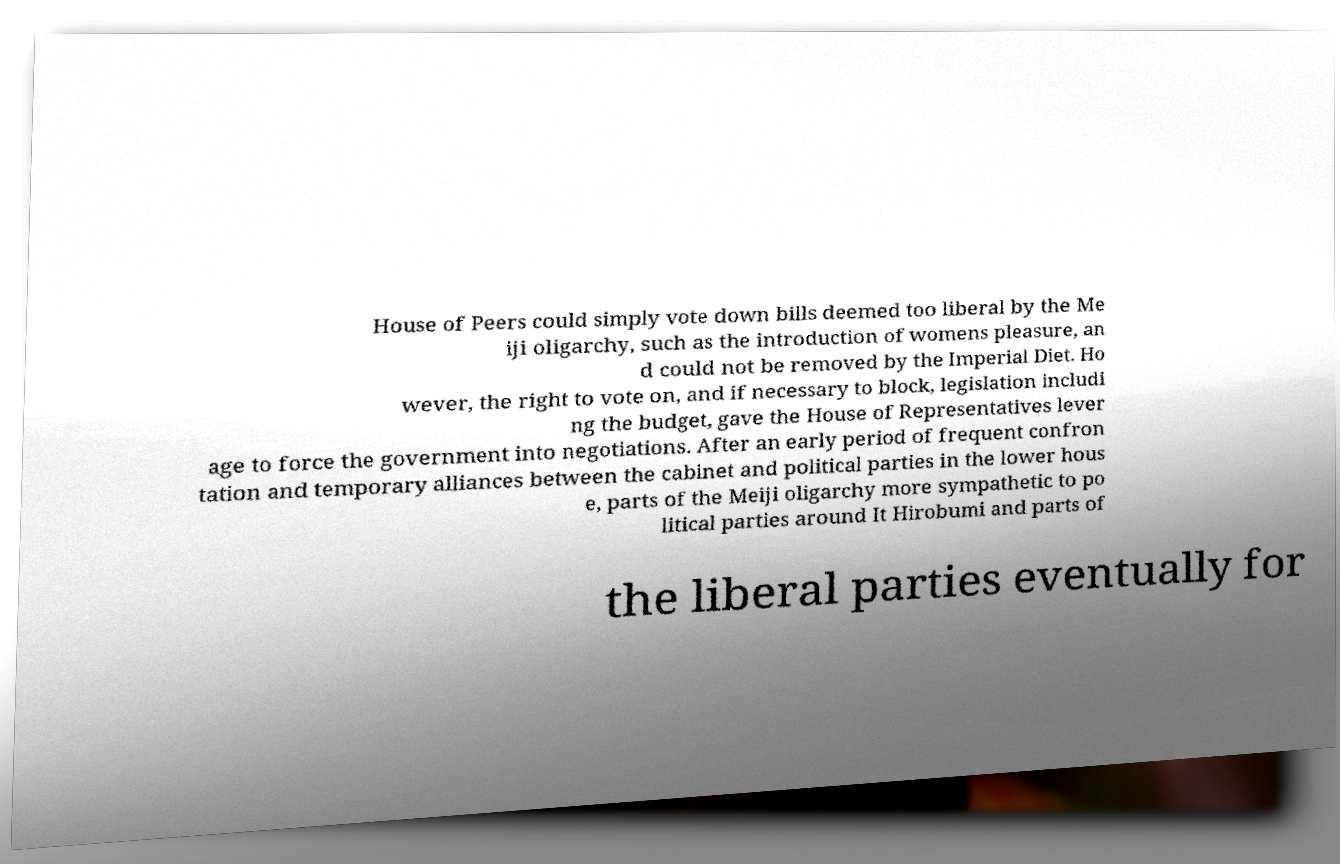Please identify and transcribe the text found in this image. House of Peers could simply vote down bills deemed too liberal by the Me iji oligarchy, such as the introduction of womens pleasure, an d could not be removed by the Imperial Diet. Ho wever, the right to vote on, and if necessary to block, legislation includi ng the budget, gave the House of Representatives lever age to force the government into negotiations. After an early period of frequent confron tation and temporary alliances between the cabinet and political parties in the lower hous e, parts of the Meiji oligarchy more sympathetic to po litical parties around It Hirobumi and parts of the liberal parties eventually for 